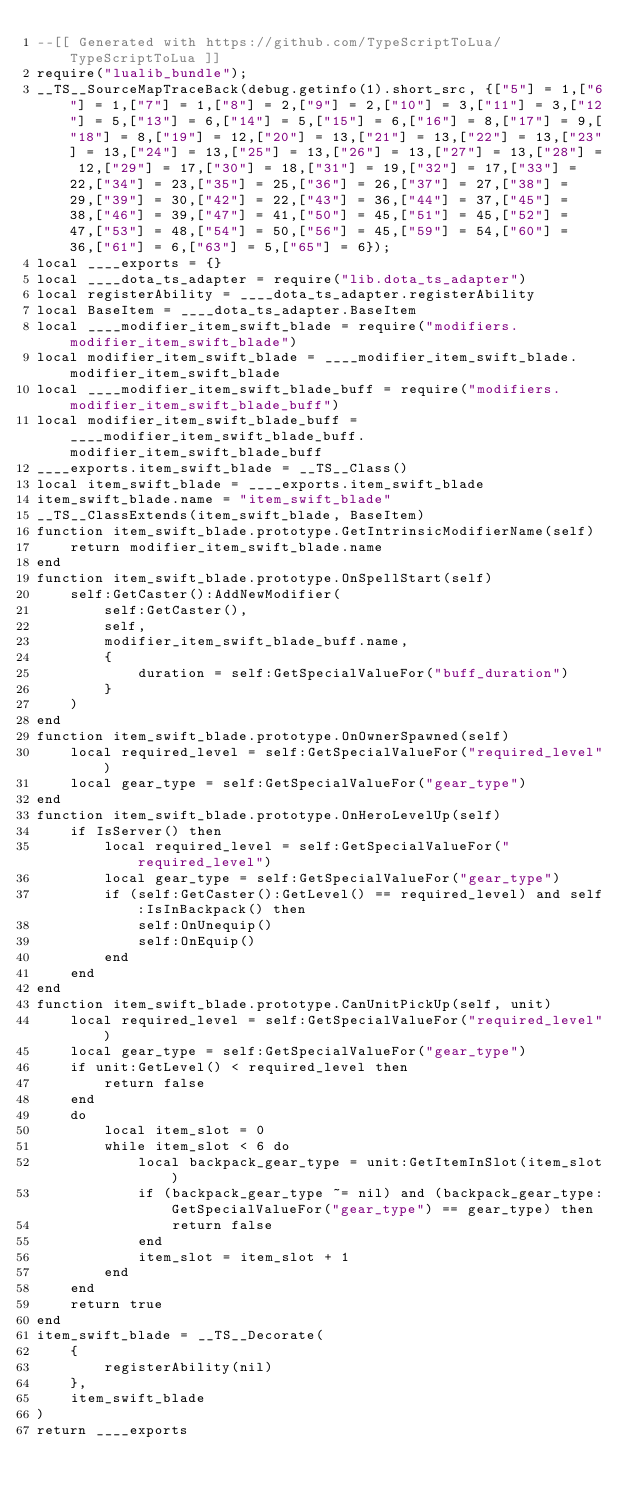<code> <loc_0><loc_0><loc_500><loc_500><_Lua_>--[[ Generated with https://github.com/TypeScriptToLua/TypeScriptToLua ]]
require("lualib_bundle");
__TS__SourceMapTraceBack(debug.getinfo(1).short_src, {["5"] = 1,["6"] = 1,["7"] = 1,["8"] = 2,["9"] = 2,["10"] = 3,["11"] = 3,["12"] = 5,["13"] = 6,["14"] = 5,["15"] = 6,["16"] = 8,["17"] = 9,["18"] = 8,["19"] = 12,["20"] = 13,["21"] = 13,["22"] = 13,["23"] = 13,["24"] = 13,["25"] = 13,["26"] = 13,["27"] = 13,["28"] = 12,["29"] = 17,["30"] = 18,["31"] = 19,["32"] = 17,["33"] = 22,["34"] = 23,["35"] = 25,["36"] = 26,["37"] = 27,["38"] = 29,["39"] = 30,["42"] = 22,["43"] = 36,["44"] = 37,["45"] = 38,["46"] = 39,["47"] = 41,["50"] = 45,["51"] = 45,["52"] = 47,["53"] = 48,["54"] = 50,["56"] = 45,["59"] = 54,["60"] = 36,["61"] = 6,["63"] = 5,["65"] = 6});
local ____exports = {}
local ____dota_ts_adapter = require("lib.dota_ts_adapter")
local registerAbility = ____dota_ts_adapter.registerAbility
local BaseItem = ____dota_ts_adapter.BaseItem
local ____modifier_item_swift_blade = require("modifiers.modifier_item_swift_blade")
local modifier_item_swift_blade = ____modifier_item_swift_blade.modifier_item_swift_blade
local ____modifier_item_swift_blade_buff = require("modifiers.modifier_item_swift_blade_buff")
local modifier_item_swift_blade_buff = ____modifier_item_swift_blade_buff.modifier_item_swift_blade_buff
____exports.item_swift_blade = __TS__Class()
local item_swift_blade = ____exports.item_swift_blade
item_swift_blade.name = "item_swift_blade"
__TS__ClassExtends(item_swift_blade, BaseItem)
function item_swift_blade.prototype.GetIntrinsicModifierName(self)
    return modifier_item_swift_blade.name
end
function item_swift_blade.prototype.OnSpellStart(self)
    self:GetCaster():AddNewModifier(
        self:GetCaster(),
        self,
        modifier_item_swift_blade_buff.name,
        {
            duration = self:GetSpecialValueFor("buff_duration")
        }
    )
end
function item_swift_blade.prototype.OnOwnerSpawned(self)
    local required_level = self:GetSpecialValueFor("required_level")
    local gear_type = self:GetSpecialValueFor("gear_type")
end
function item_swift_blade.prototype.OnHeroLevelUp(self)
    if IsServer() then
        local required_level = self:GetSpecialValueFor("required_level")
        local gear_type = self:GetSpecialValueFor("gear_type")
        if (self:GetCaster():GetLevel() == required_level) and self:IsInBackpack() then
            self:OnUnequip()
            self:OnEquip()
        end
    end
end
function item_swift_blade.prototype.CanUnitPickUp(self, unit)
    local required_level = self:GetSpecialValueFor("required_level")
    local gear_type = self:GetSpecialValueFor("gear_type")
    if unit:GetLevel() < required_level then
        return false
    end
    do
        local item_slot = 0
        while item_slot < 6 do
            local backpack_gear_type = unit:GetItemInSlot(item_slot)
            if (backpack_gear_type ~= nil) and (backpack_gear_type:GetSpecialValueFor("gear_type") == gear_type) then
                return false
            end
            item_slot = item_slot + 1
        end
    end
    return true
end
item_swift_blade = __TS__Decorate(
    {
        registerAbility(nil)
    },
    item_swift_blade
)
return ____exports
</code> 